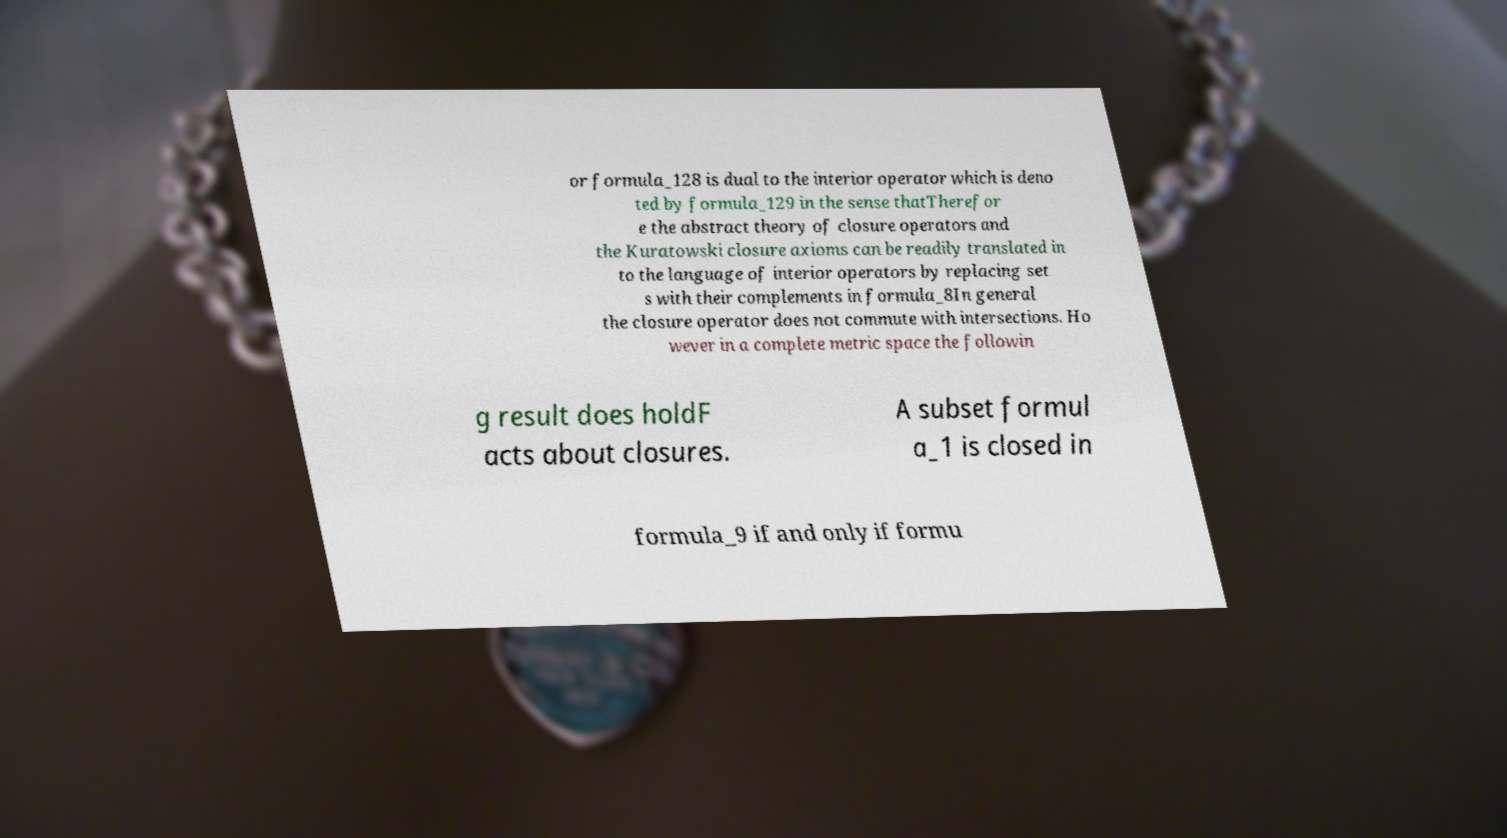What messages or text are displayed in this image? I need them in a readable, typed format. or formula_128 is dual to the interior operator which is deno ted by formula_129 in the sense thatTherefor e the abstract theory of closure operators and the Kuratowski closure axioms can be readily translated in to the language of interior operators by replacing set s with their complements in formula_8In general the closure operator does not commute with intersections. Ho wever in a complete metric space the followin g result does holdF acts about closures. A subset formul a_1 is closed in formula_9 if and only if formu 